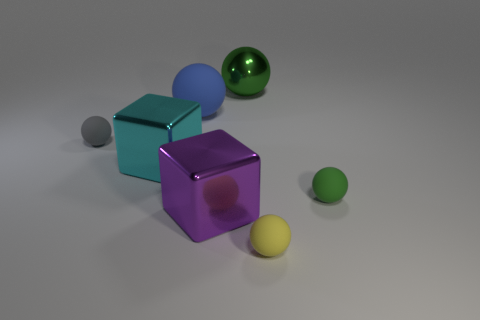There is a gray sphere that is the same size as the yellow matte ball; what material is it? rubber 